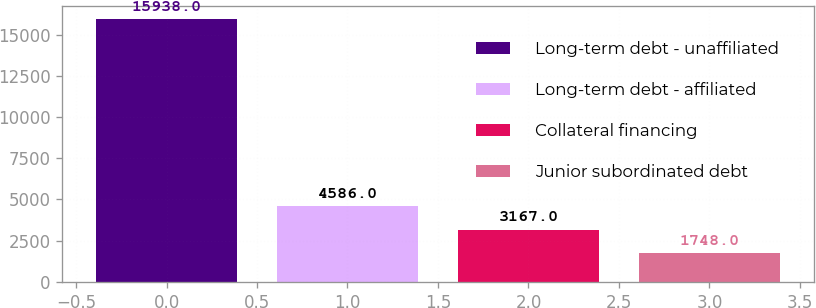<chart> <loc_0><loc_0><loc_500><loc_500><bar_chart><fcel>Long-term debt - unaffiliated<fcel>Long-term debt - affiliated<fcel>Collateral financing<fcel>Junior subordinated debt<nl><fcel>15938<fcel>4586<fcel>3167<fcel>1748<nl></chart> 